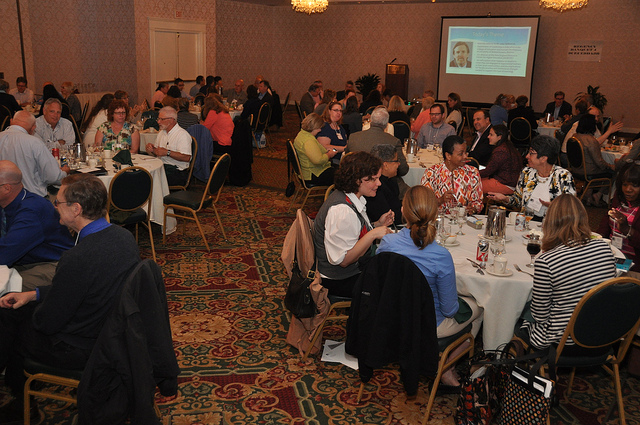Can you describe the attire of the people? Most attendees are dressed in business or business casual attire, with a combination of suits, jackets, dresses, and shirts visible, which aligns with a professional gathering. Does the image suggest any particular time of the day? There are no clear indicators of the time of day within this indoor setting. The lighting appears to be that of indoor artificial lighting, which doesn't provide conclusive information about the time outside. 